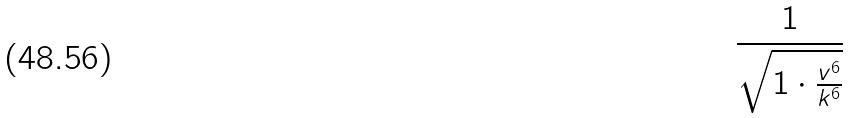Convert formula to latex. <formula><loc_0><loc_0><loc_500><loc_500>\frac { 1 } { \sqrt { 1 \cdot \frac { v ^ { 6 } } { k ^ { 6 } } } }</formula> 